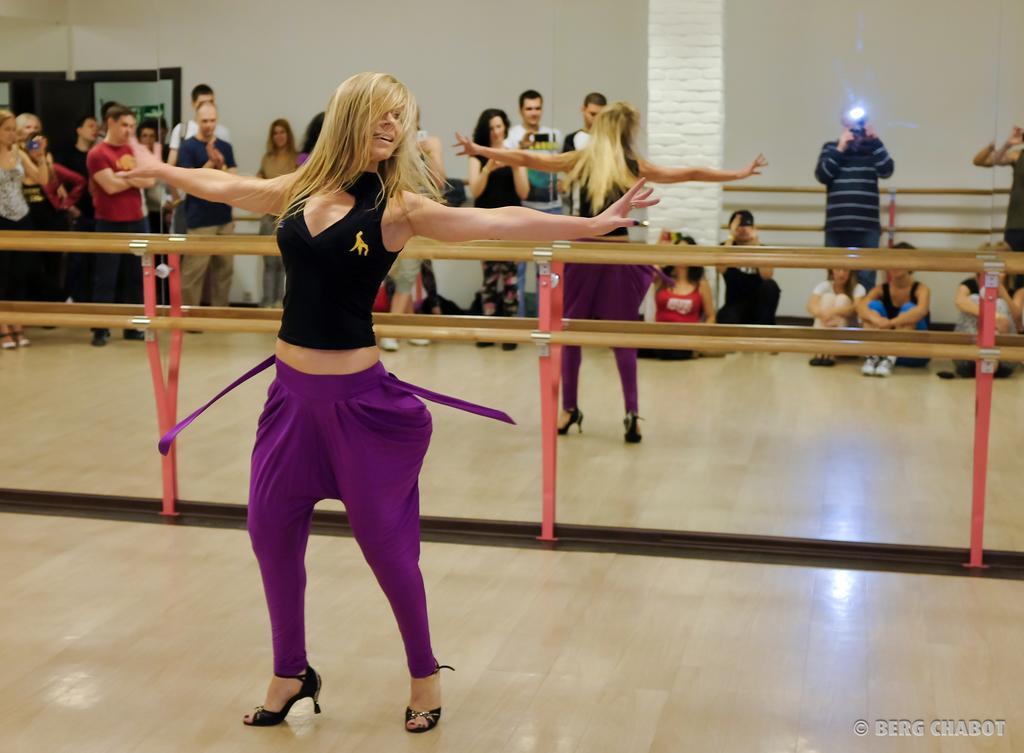In one or two sentences, can you explain what this image depicts? In this image, we can see persons wearing clothes. There are safety grills in the middle of the image. There is a wall at the top of the image. 